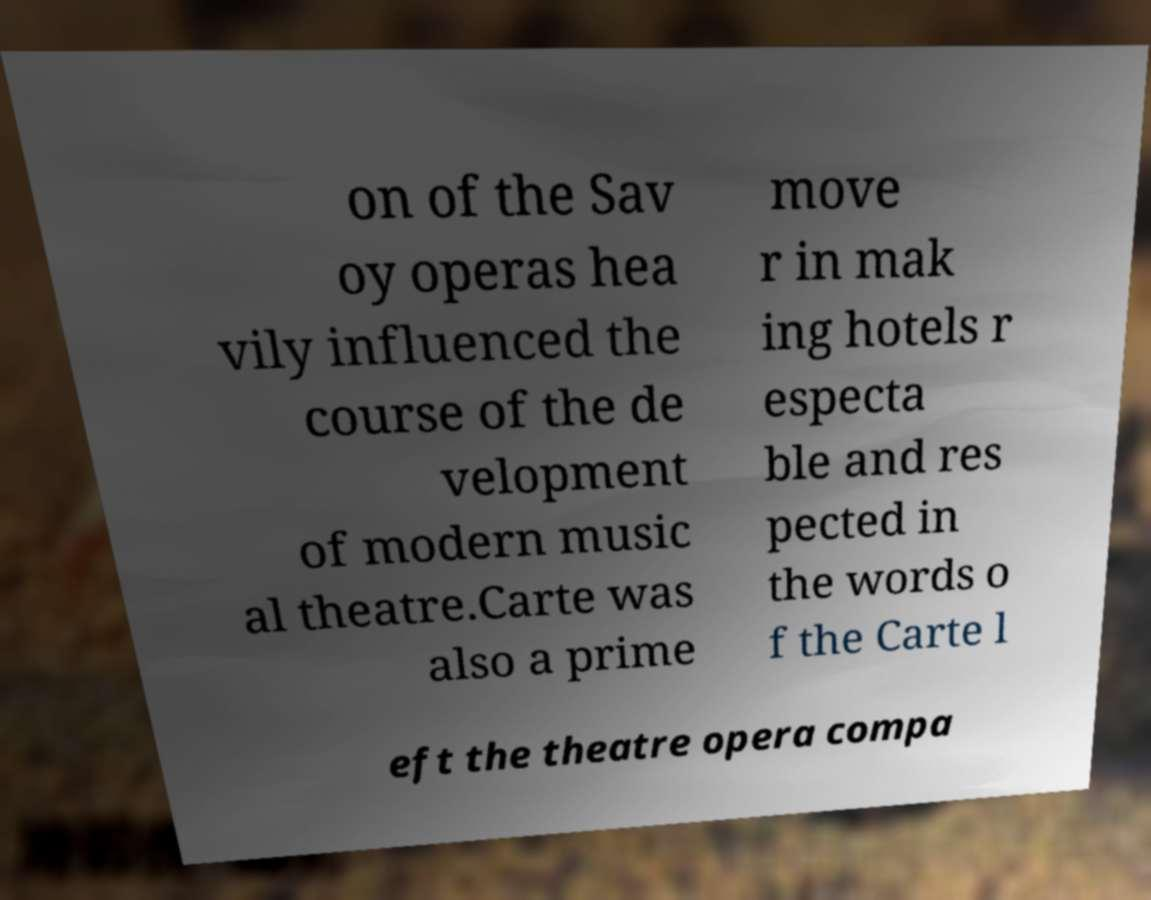Please identify and transcribe the text found in this image. on of the Sav oy operas hea vily influenced the course of the de velopment of modern music al theatre.Carte was also a prime move r in mak ing hotels r especta ble and res pected in the words o f the Carte l eft the theatre opera compa 